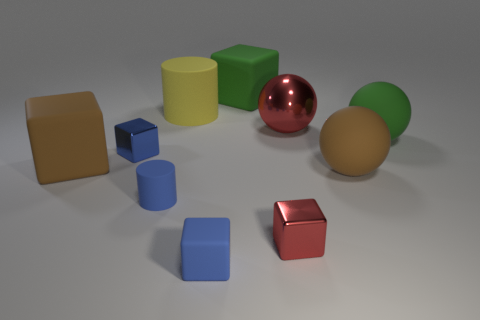Subtract all brown blocks. How many blocks are left? 4 Subtract all cyan cylinders. How many blue cubes are left? 2 Subtract all green blocks. How many blocks are left? 4 Subtract all balls. How many objects are left? 7 Subtract 0 purple spheres. How many objects are left? 10 Subtract all blue cylinders. Subtract all brown cubes. How many cylinders are left? 1 Subtract all metal balls. Subtract all tiny blue metallic blocks. How many objects are left? 8 Add 5 metallic things. How many metallic things are left? 8 Add 1 big cylinders. How many big cylinders exist? 2 